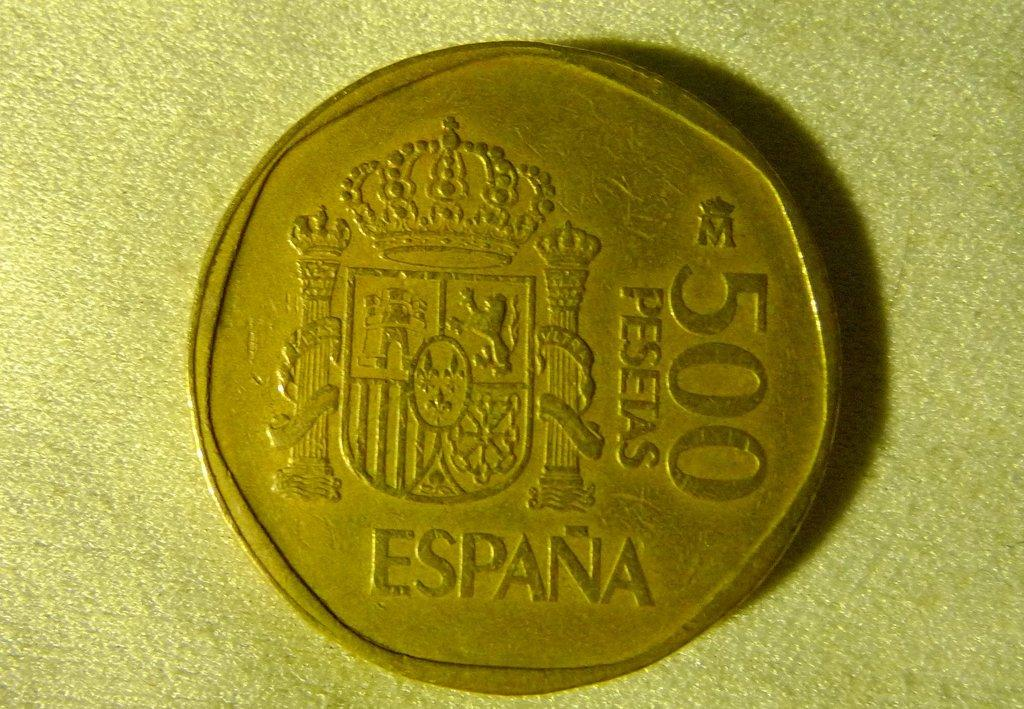<image>
Create a compact narrative representing the image presented. A coin reading 500 Pesetas sits on a cloth surface. 